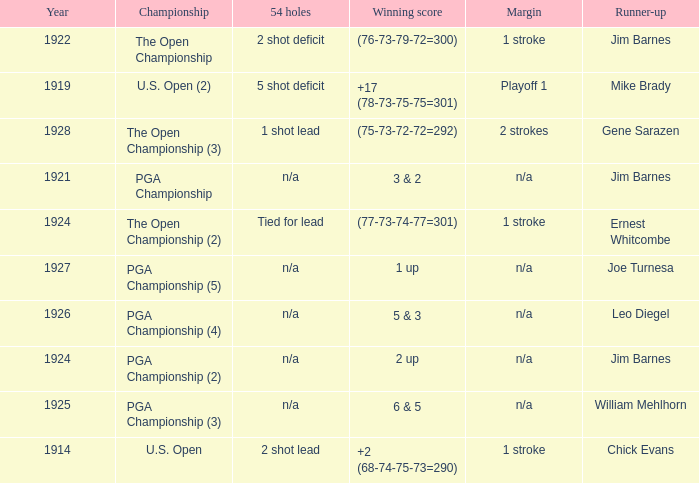WHAT WAS THE WINNING SCORE IN YEAR 1922? (76-73-79-72=300). 